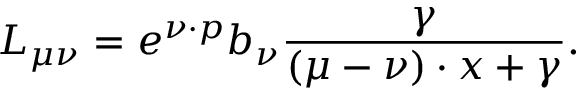Convert formula to latex. <formula><loc_0><loc_0><loc_500><loc_500>L _ { \mu \nu } = e ^ { \nu \cdot p } b _ { \nu } \frac { \gamma } { ( \mu - \nu ) \cdot x + \gamma } .</formula> 